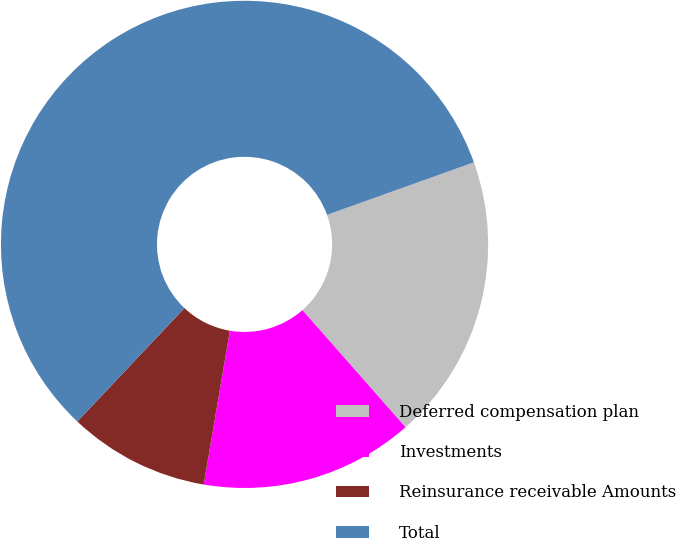<chart> <loc_0><loc_0><loc_500><loc_500><pie_chart><fcel>Deferred compensation plan<fcel>Investments<fcel>Reinsurance receivable Amounts<fcel>Total<nl><fcel>18.98%<fcel>14.17%<fcel>9.36%<fcel>57.49%<nl></chart> 